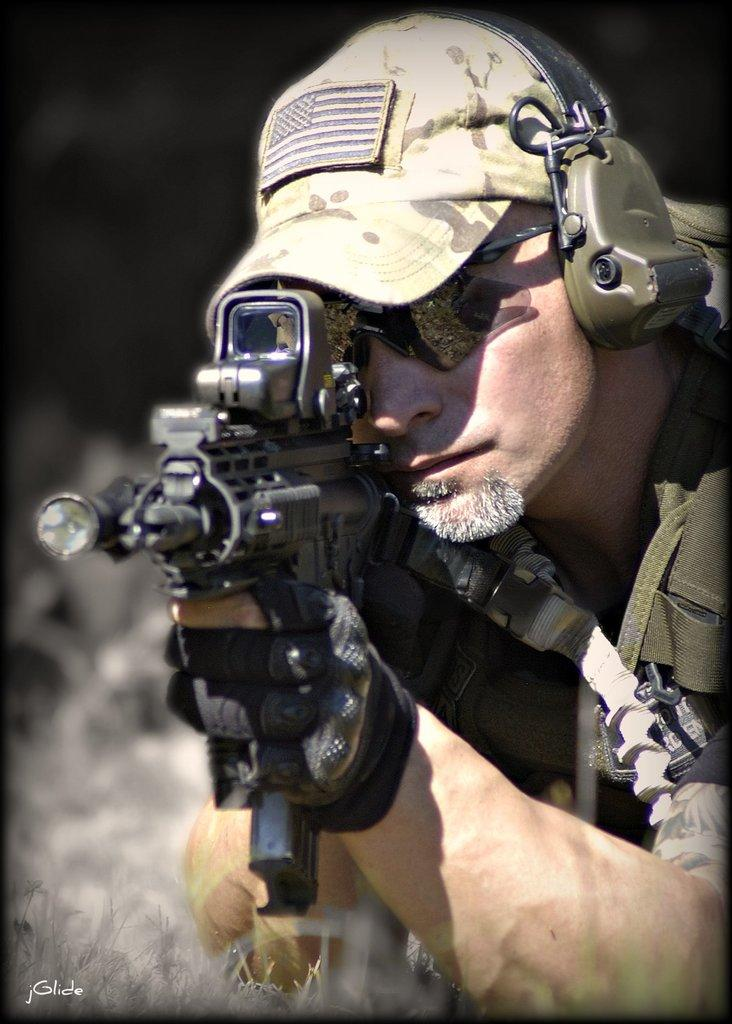Who is present in the image? There is a man in the image. What is the man holding in his hands? The man is holding a gun in his hands. What type of headgear is the man wearing? The man is wearing a cap. What is the man wearing on his ears? The man is wearing a headset. Can you describe the background of the image? The background of the image is blurred, but there are objects visible in it. What type of tent can be seen in the background of the image? There is no tent present in the image; the background is blurred and only objects are visible. 